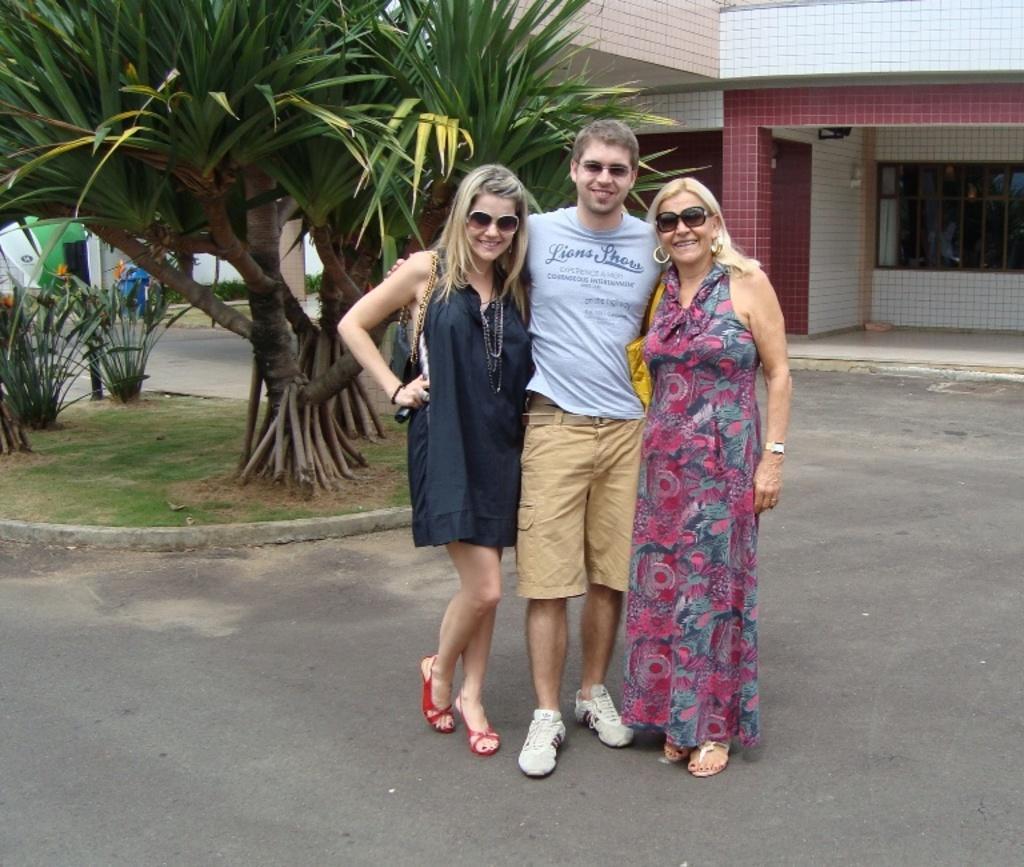Please provide a concise description of this image. This is an outside view. Here two women and a man are standing on the road. They are smiling and giving pose for the picture. At the back of these people there are few plants. In the background there is a building. 